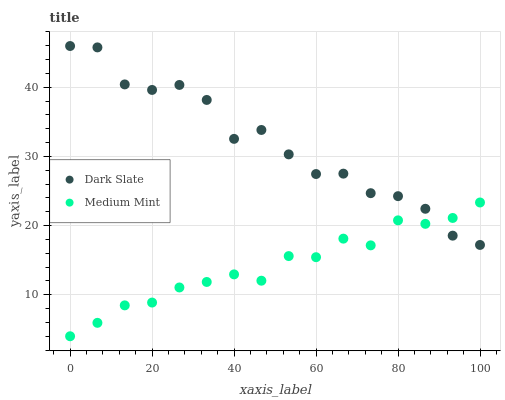Does Medium Mint have the minimum area under the curve?
Answer yes or no. Yes. Does Dark Slate have the maximum area under the curve?
Answer yes or no. Yes. Does Dark Slate have the minimum area under the curve?
Answer yes or no. No. Is Medium Mint the smoothest?
Answer yes or no. Yes. Is Dark Slate the roughest?
Answer yes or no. Yes. Is Dark Slate the smoothest?
Answer yes or no. No. Does Medium Mint have the lowest value?
Answer yes or no. Yes. Does Dark Slate have the lowest value?
Answer yes or no. No. Does Dark Slate have the highest value?
Answer yes or no. Yes. Does Dark Slate intersect Medium Mint?
Answer yes or no. Yes. Is Dark Slate less than Medium Mint?
Answer yes or no. No. Is Dark Slate greater than Medium Mint?
Answer yes or no. No. 